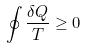<formula> <loc_0><loc_0><loc_500><loc_500>\oint \frac { \delta Q } { T } \geq 0</formula> 